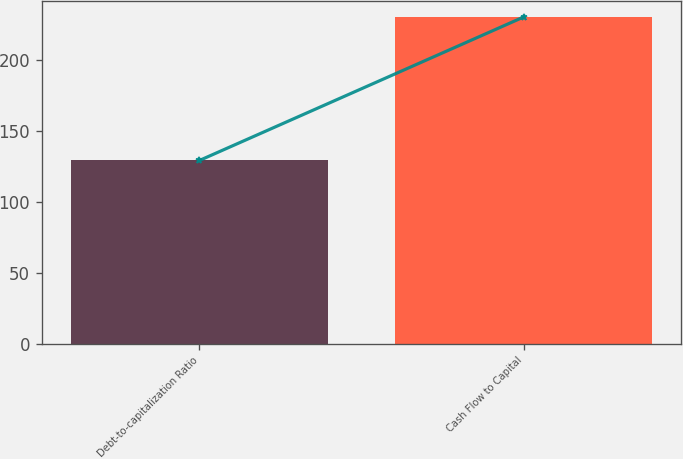Convert chart to OTSL. <chart><loc_0><loc_0><loc_500><loc_500><bar_chart><fcel>Debt-to-capitalization Ratio<fcel>Cash Flow to Capital<nl><fcel>129<fcel>230<nl></chart> 